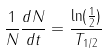<formula> <loc_0><loc_0><loc_500><loc_500>\frac { 1 } { N } \frac { d N } { d t } = \frac { \ln ( \frac { 1 } { 2 } ) } { T _ { 1 / 2 } }</formula> 